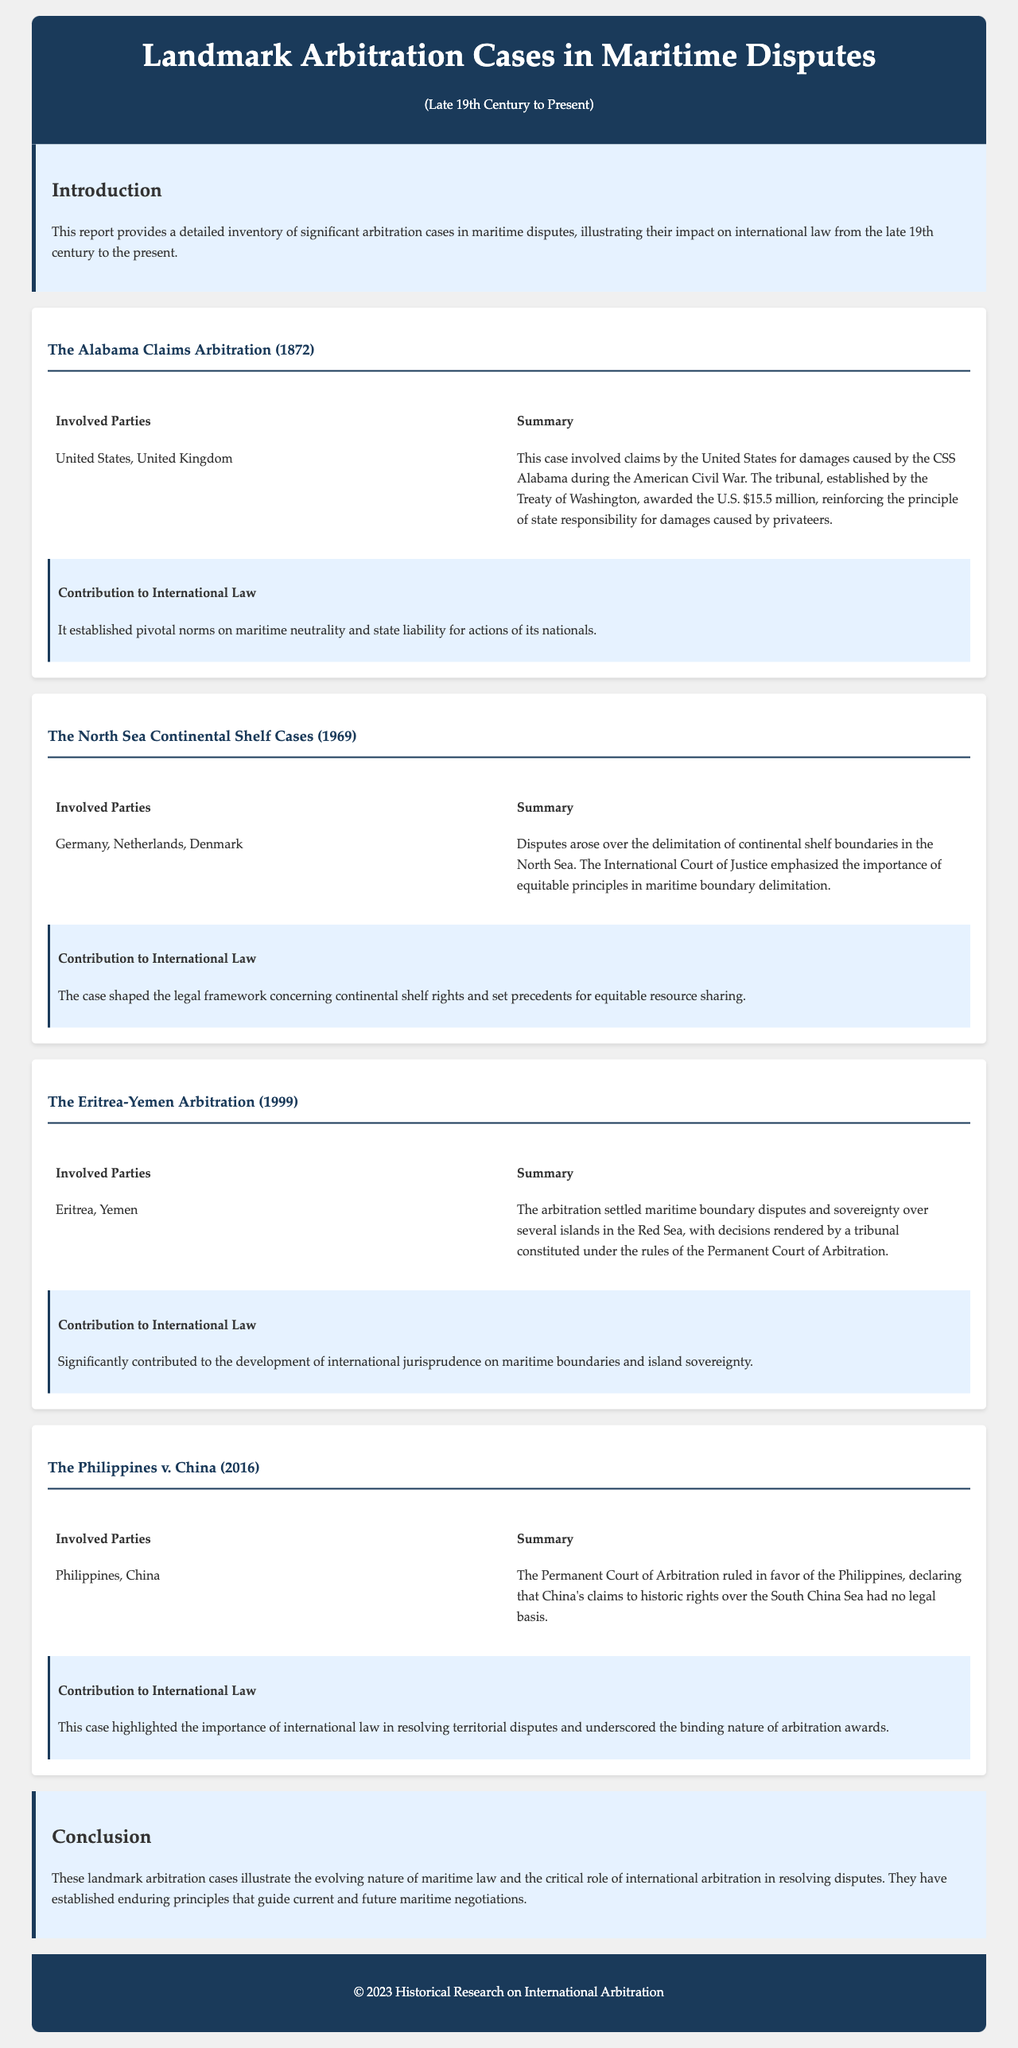What is the title of the report? The title of the report is prominently displayed at the top of the document.
Answer: Landmark Arbitration Cases in Maritime Disputes In what year did The Alabama Claims Arbitration take place? The year of The Alabama Claims Arbitration is stated in the subtitle of the case section.
Answer: 1872 Who were the involved parties in The North Sea Continental Shelf Cases? The involved parties are explicitly mentioned in the case details section.
Answer: Germany, Netherlands, Denmark What was awarded to the United States in The Alabama Claims Arbitration? The amount awarded to the United States is specified in the summary of the case.
Answer: $15.5 million Which case highlighted the importance of international law in resolving territorial disputes? The reasoning is based on the significance mentioned in the contribution section of the case.
Answer: The Philippines v. China What principle did The North Sea Continental Shelf Cases emphasize? This principle is detailed in the summary of the case.
Answer: Equitable principles in maritime boundary delimitation What tribunal was used in The Eritrea-Yemen Arbitration? The name of the tribunal is provided in the summary of the case details.
Answer: Permanent Court of Arbitration What year did The Philippines v. China case occur? The year of this arbitration case is not explicitly stated in the case summary but is commonly known.
Answer: 2016 